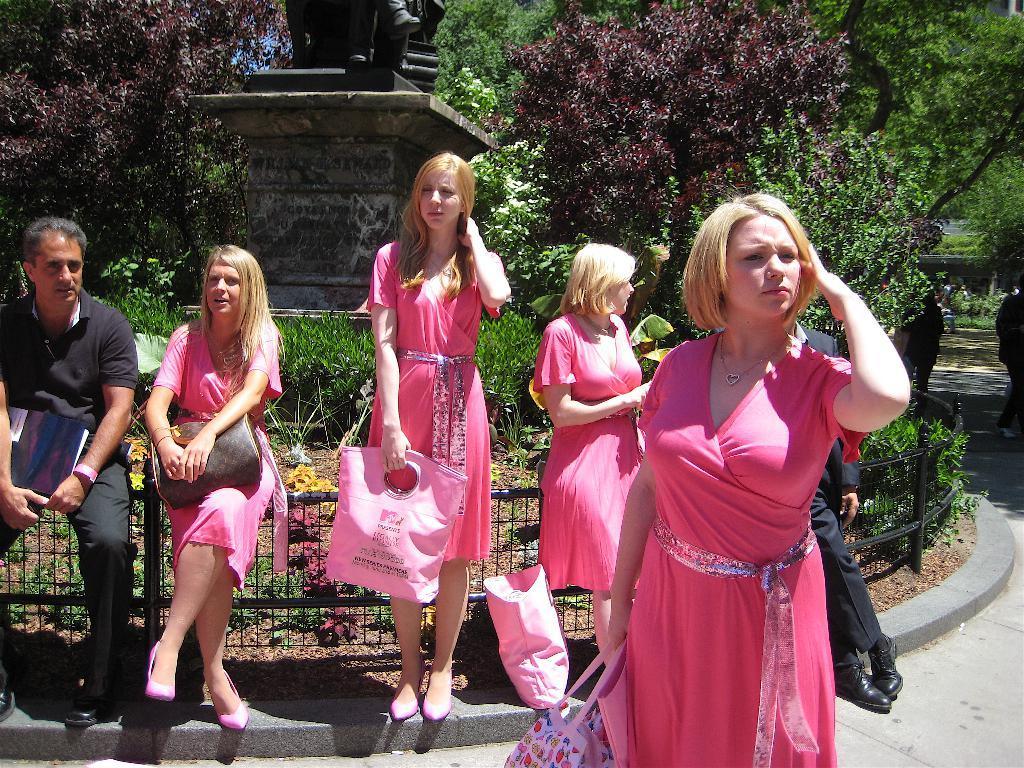Could you give a brief overview of what you see in this image? Here we can see people. These women wore pink dress and these two people are holding bags. This man is holding a book. Background we can see statues, plants, fence and trees.  